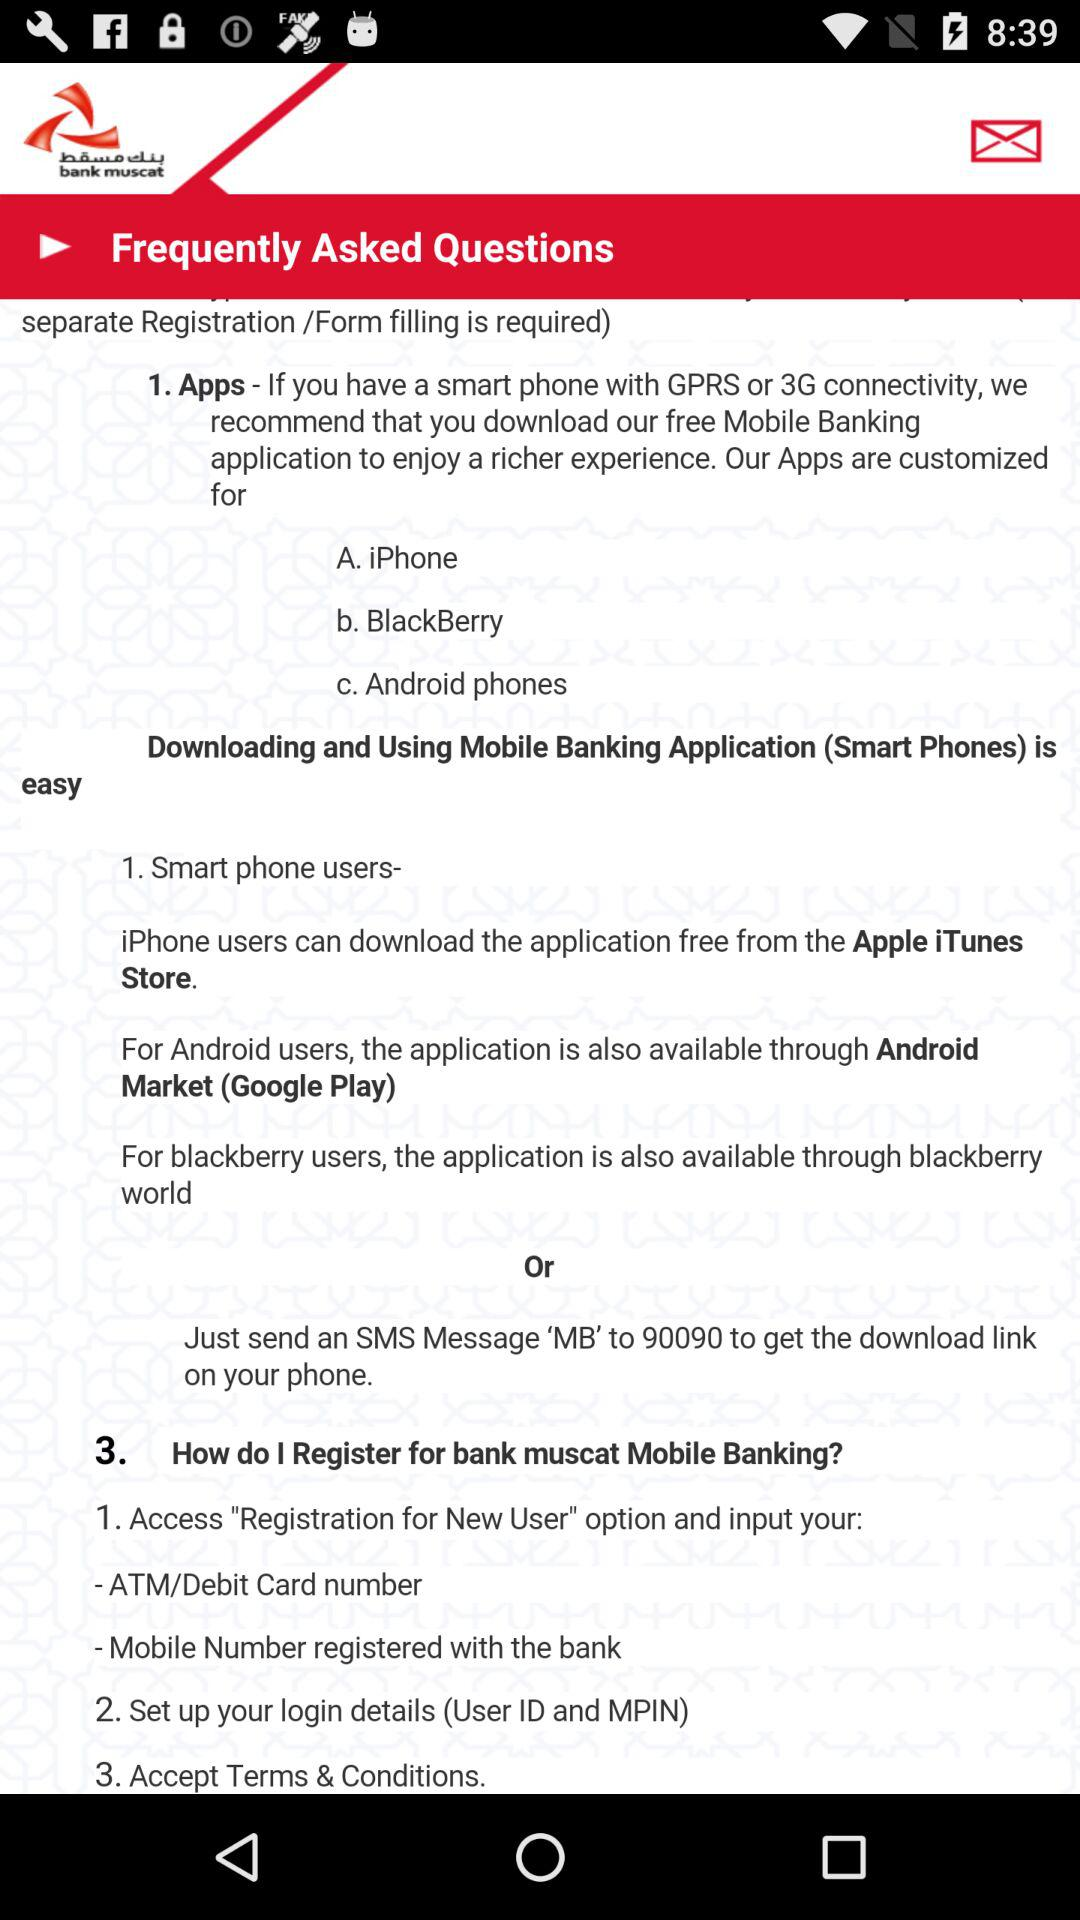How many ways can I download the Mobile Banking application?
Answer the question using a single word or phrase. 3 